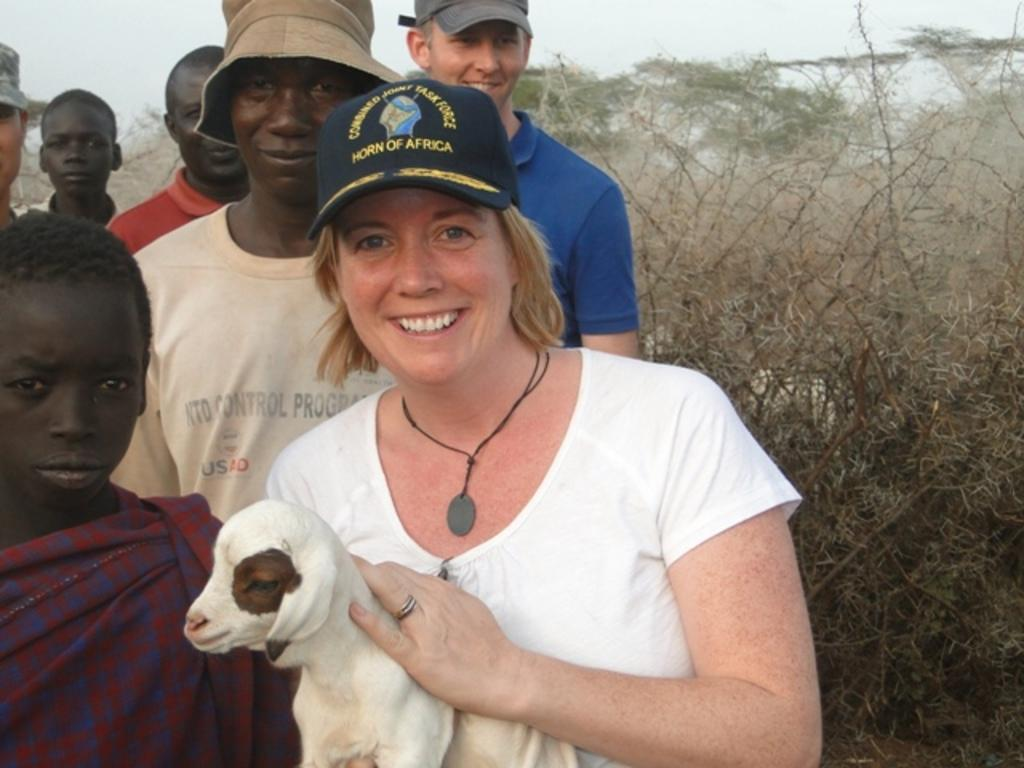What is happening in the image involving the group of people? The people in the image are standing and smiling. Can you describe the appearance of one of the individuals in the group? A woman is wearing a cap. What is the woman doing with her hands in the image? The woman is holding an animal with her hands. What type of natural environment is visible in the image? There are trees in the image. What can be seen in the background of the image? The sky is visible in the background of the image. What type of music is being played by the authority figure in the image? There is no authority figure or music present in the image. How many dimes can be seen on the ground in the image? There are no dimes visible in the image. 